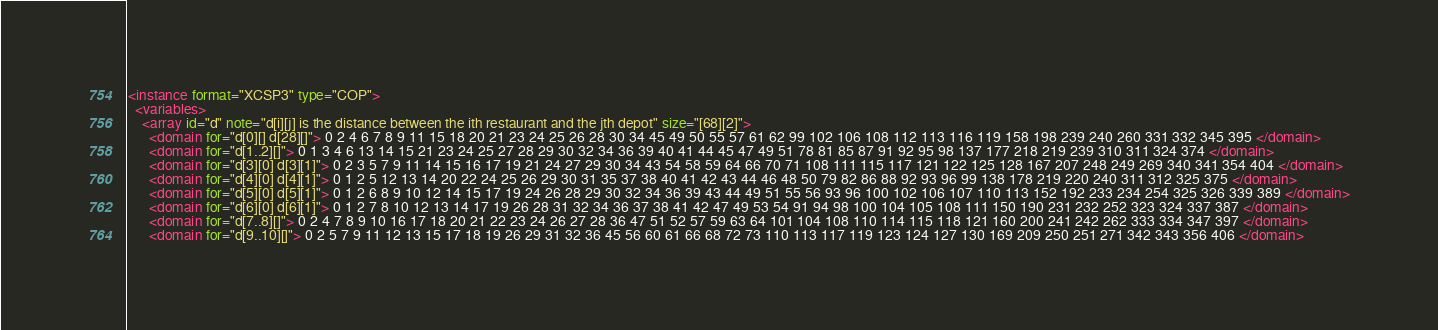<code> <loc_0><loc_0><loc_500><loc_500><_XML_><instance format="XCSP3" type="COP">
  <variables>
    <array id="d" note="d[i][j] is the distance between the ith restaurant and the jth depot" size="[68][2]">
      <domain for="d[0][] d[28][]"> 0 2 4 6 7 8 9 11 15 18 20 21 23 24 25 26 28 30 34 45 49 50 55 57 61 62 99 102 106 108 112 113 116 119 158 198 239 240 260 331 332 345 395 </domain>
      <domain for="d[1..2][]"> 0 1 3 4 6 13 14 15 21 23 24 25 27 28 29 30 32 34 36 39 40 41 44 45 47 49 51 78 81 85 87 91 92 95 98 137 177 218 219 239 310 311 324 374 </domain>
      <domain for="d[3][0] d[3][1]"> 0 2 3 5 7 9 11 14 15 16 17 19 21 24 27 29 30 34 43 54 58 59 64 66 70 71 108 111 115 117 121 122 125 128 167 207 248 249 269 340 341 354 404 </domain>
      <domain for="d[4][0] d[4][1]"> 0 1 2 5 12 13 14 20 22 24 25 26 29 30 31 35 37 38 40 41 42 43 44 46 48 50 79 82 86 88 92 93 96 99 138 178 219 220 240 311 312 325 375 </domain>
      <domain for="d[5][0] d[5][1]"> 0 1 2 6 8 9 10 12 14 15 17 19 24 26 28 29 30 32 34 36 39 43 44 49 51 55 56 93 96 100 102 106 107 110 113 152 192 233 234 254 325 326 339 389 </domain>
      <domain for="d[6][0] d[6][1]"> 0 1 2 7 8 10 12 13 14 17 19 26 28 31 32 34 36 37 38 41 42 47 49 53 54 91 94 98 100 104 105 108 111 150 190 231 232 252 323 324 337 387 </domain>
      <domain for="d[7..8][]"> 0 2 4 7 8 9 10 16 17 18 20 21 22 23 24 26 27 28 36 47 51 52 57 59 63 64 101 104 108 110 114 115 118 121 160 200 241 242 262 333 334 347 397 </domain>
      <domain for="d[9..10][]"> 0 2 5 7 9 11 12 13 15 17 18 19 26 29 31 32 36 45 56 60 61 66 68 72 73 110 113 117 119 123 124 127 130 169 209 250 251 271 342 343 356 406 </domain></code> 